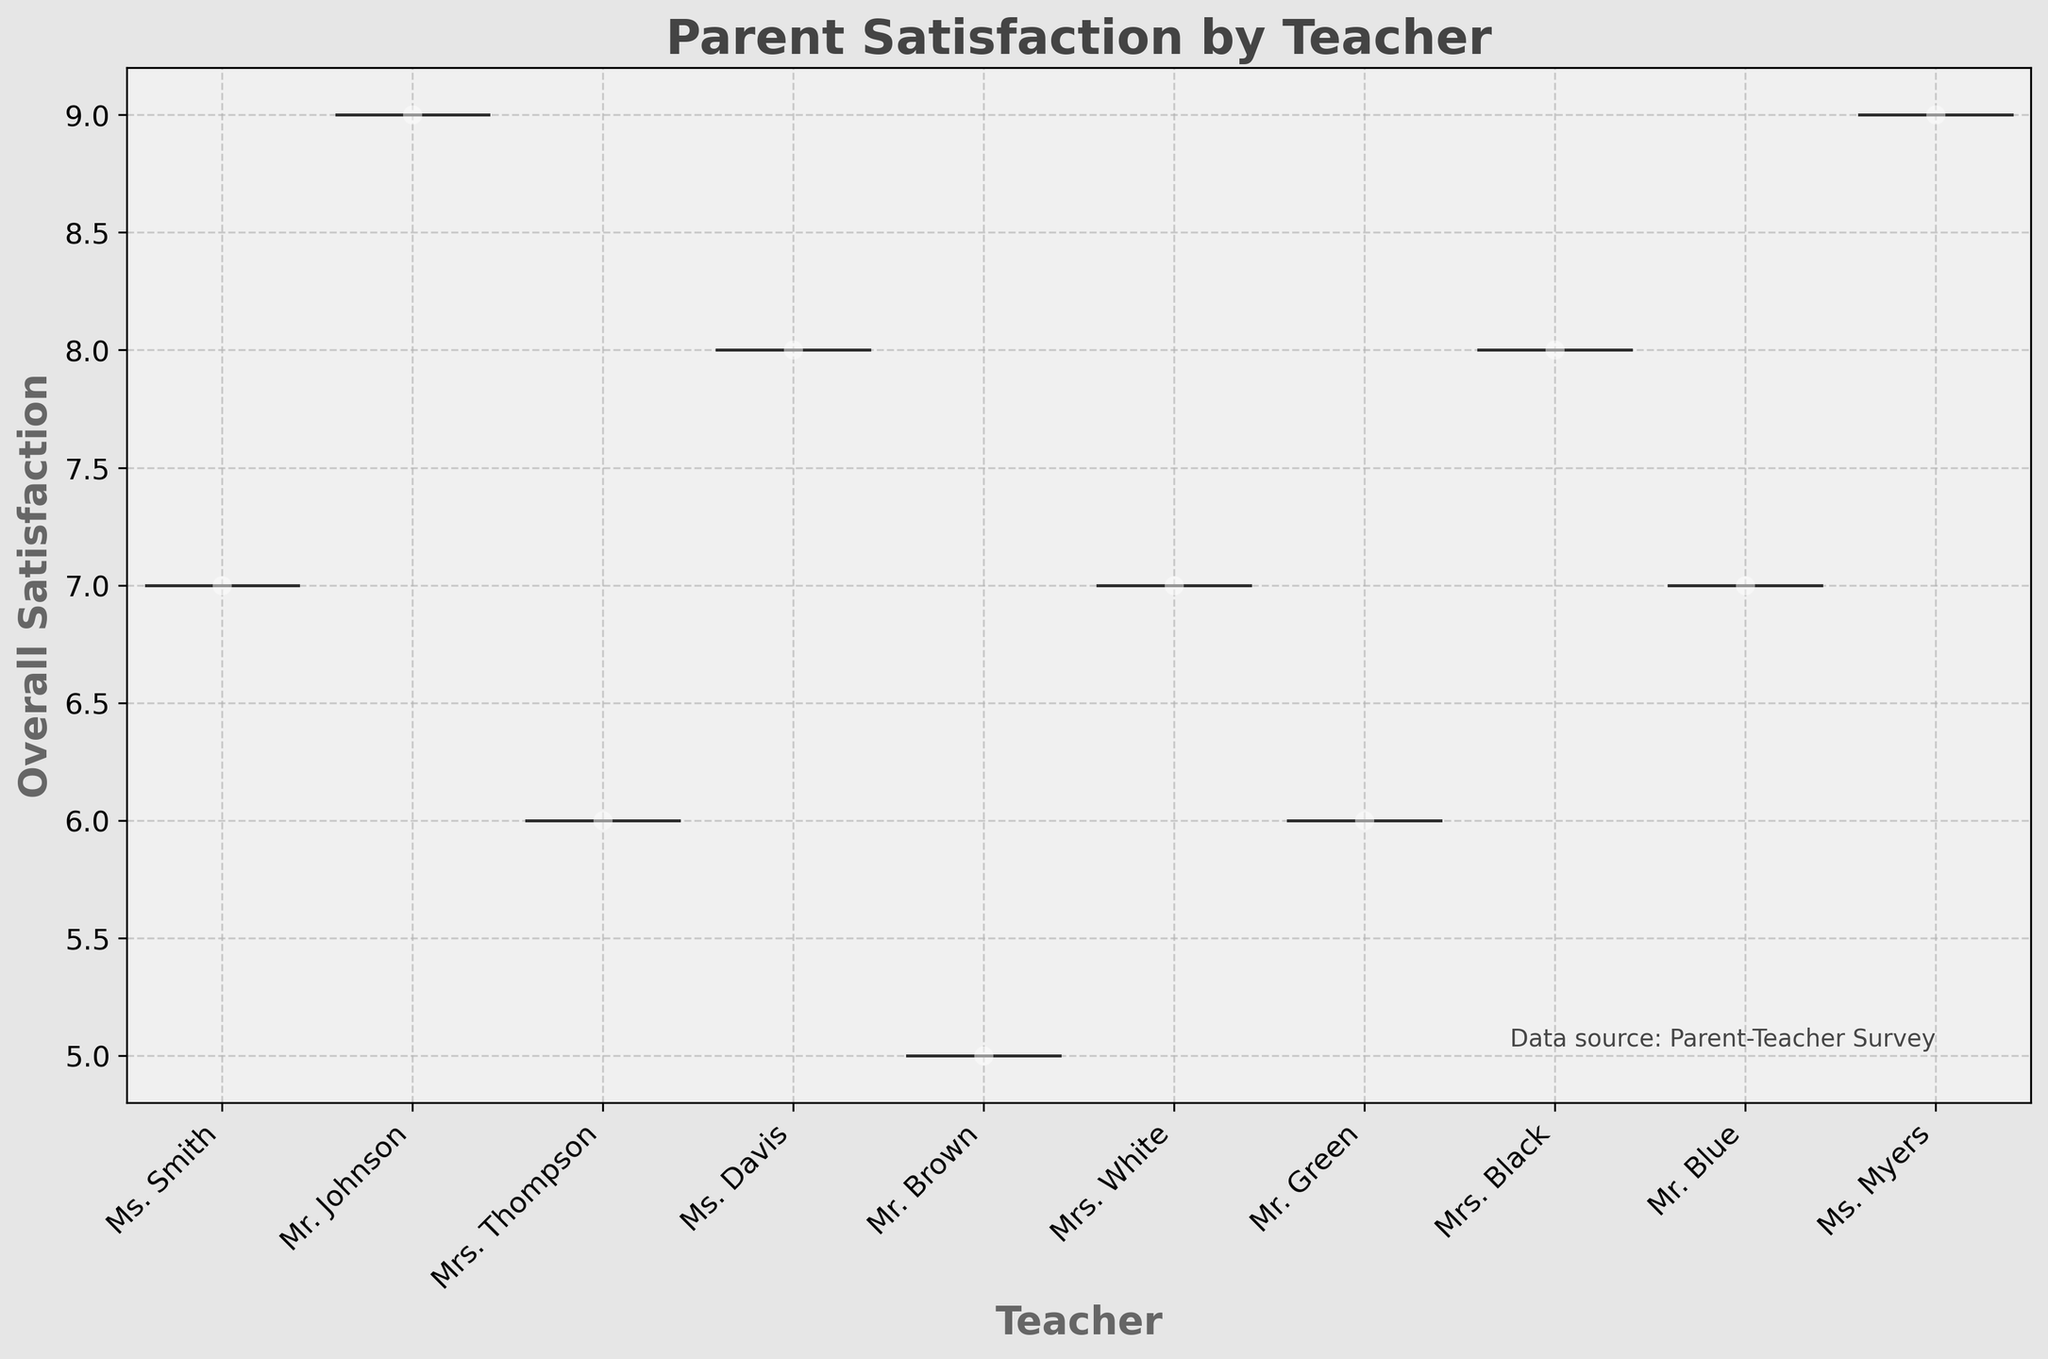How many teachers are displayed in the plot? The x-axis of the figure represents different teachers. By counting the unique teacher names on the x-axis, we determine the number of teachers.
Answer: 8 What is the range of overall satisfaction scores? The y-axis represents the overall satisfaction scores. By looking at the minimum and maximum values on the y-axis, we can determine the range.
Answer: 5 to 9 Which teacher has the highest median satisfaction score? In a violin plot, the median is typically displayed as a white dot or a line within the wider part of the plot. By comparing the positions of these medians across all teachers, we can determine the teacher with the highest median score.
Answer: Mr. Johnson Are there any teachers with the same median satisfaction score? By visually comparing the positions of the median points or lines within the violin plots for each teacher, we can determine if any teachers have the same median satisfaction score.
Answer: Mrs. Thompson and Mrs. White How many data points are shown for 'Ms. Smith'? The jittered points represent individual ratings. By counting these points specifically within the section for 'Ms. Smith' on the x-axis, we determine the number of data points.
Answer: 1 Which teacher shows the most variability in satisfaction scores? Variability can be observed by the width and spread of each violin plot. The broader and more spread out the plot, the greater the variability.
Answer: Ms. Davis Which teacher has the narrowest range of satisfaction scores? The narrowest range can be determined by looking at the most compressed violin plot vertically.
Answer: Ms. Smith What is the combined median score of 'Mr. Blue' and 'Mrs. Black'? Determine the median scores of 'Mr. Blue' and 'Mrs. Black' from the positions of their respective white dots/lines, then add the two median scores together.
Answer: 15 What does the title of the plot convey? The title is usually located at the top of the plot and provides a summary of what the figure represents.
Answer: Parent Satisfaction by Teacher What is the relationship between communication frequency and overall satisfaction for Paul Walker? Check the specific data points for Paul Walker (as jittered points for the teacher 'Ms. Myers') in the context of his given communication frequency value and overall satisfaction score from the data.
Answer: Positive (3 frequency, 9 satisfaction) 